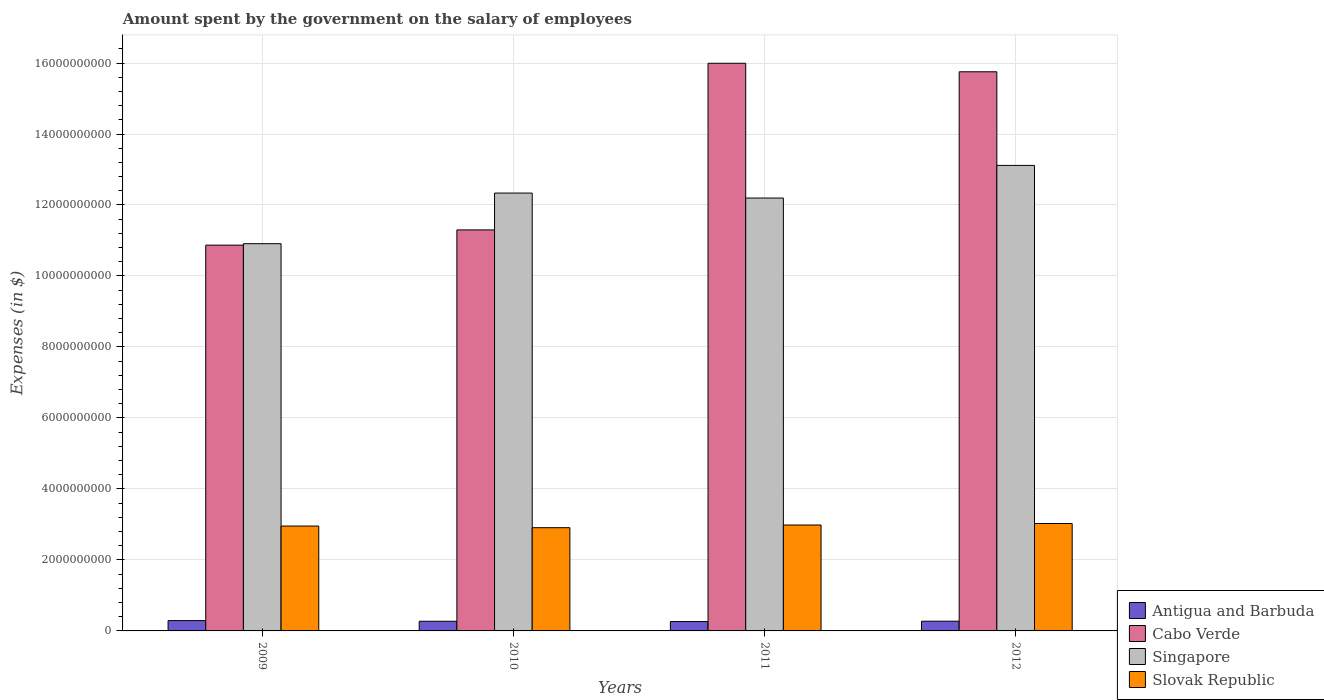How many different coloured bars are there?
Offer a very short reply. 4. How many groups of bars are there?
Offer a very short reply. 4. Are the number of bars per tick equal to the number of legend labels?
Offer a terse response. Yes. Are the number of bars on each tick of the X-axis equal?
Keep it short and to the point. Yes. How many bars are there on the 4th tick from the right?
Ensure brevity in your answer.  4. What is the label of the 4th group of bars from the left?
Provide a short and direct response. 2012. In how many cases, is the number of bars for a given year not equal to the number of legend labels?
Ensure brevity in your answer.  0. What is the amount spent on the salary of employees by the government in Singapore in 2010?
Provide a succinct answer. 1.23e+1. Across all years, what is the maximum amount spent on the salary of employees by the government in Cabo Verde?
Your response must be concise. 1.60e+1. Across all years, what is the minimum amount spent on the salary of employees by the government in Antigua and Barbuda?
Offer a terse response. 2.64e+08. In which year was the amount spent on the salary of employees by the government in Slovak Republic maximum?
Your answer should be compact. 2012. In which year was the amount spent on the salary of employees by the government in Antigua and Barbuda minimum?
Offer a very short reply. 2011. What is the total amount spent on the salary of employees by the government in Antigua and Barbuda in the graph?
Make the answer very short. 1.10e+09. What is the difference between the amount spent on the salary of employees by the government in Antigua and Barbuda in 2011 and that in 2012?
Provide a succinct answer. -9.90e+06. What is the difference between the amount spent on the salary of employees by the government in Antigua and Barbuda in 2010 and the amount spent on the salary of employees by the government in Cabo Verde in 2012?
Your response must be concise. -1.55e+1. What is the average amount spent on the salary of employees by the government in Singapore per year?
Offer a terse response. 1.21e+1. In the year 2012, what is the difference between the amount spent on the salary of employees by the government in Singapore and amount spent on the salary of employees by the government in Slovak Republic?
Offer a terse response. 1.01e+1. What is the ratio of the amount spent on the salary of employees by the government in Slovak Republic in 2010 to that in 2011?
Provide a succinct answer. 0.97. Is the amount spent on the salary of employees by the government in Antigua and Barbuda in 2011 less than that in 2012?
Offer a very short reply. Yes. What is the difference between the highest and the second highest amount spent on the salary of employees by the government in Slovak Republic?
Offer a terse response. 4.21e+07. What is the difference between the highest and the lowest amount spent on the salary of employees by the government in Antigua and Barbuda?
Your response must be concise. 2.68e+07. In how many years, is the amount spent on the salary of employees by the government in Antigua and Barbuda greater than the average amount spent on the salary of employees by the government in Antigua and Barbuda taken over all years?
Ensure brevity in your answer.  1. What does the 2nd bar from the left in 2009 represents?
Your response must be concise. Cabo Verde. What does the 1st bar from the right in 2011 represents?
Your answer should be very brief. Slovak Republic. How many bars are there?
Provide a short and direct response. 16. What is the difference between two consecutive major ticks on the Y-axis?
Offer a terse response. 2.00e+09. How many legend labels are there?
Offer a terse response. 4. How are the legend labels stacked?
Your answer should be very brief. Vertical. What is the title of the graph?
Your answer should be compact. Amount spent by the government on the salary of employees. Does "Trinidad and Tobago" appear as one of the legend labels in the graph?
Offer a very short reply. No. What is the label or title of the Y-axis?
Offer a terse response. Expenses (in $). What is the Expenses (in $) of Antigua and Barbuda in 2009?
Your response must be concise. 2.91e+08. What is the Expenses (in $) of Cabo Verde in 2009?
Give a very brief answer. 1.09e+1. What is the Expenses (in $) of Singapore in 2009?
Keep it short and to the point. 1.09e+1. What is the Expenses (in $) of Slovak Republic in 2009?
Ensure brevity in your answer.  2.96e+09. What is the Expenses (in $) in Antigua and Barbuda in 2010?
Make the answer very short. 2.73e+08. What is the Expenses (in $) in Cabo Verde in 2010?
Your answer should be very brief. 1.13e+1. What is the Expenses (in $) in Singapore in 2010?
Give a very brief answer. 1.23e+1. What is the Expenses (in $) in Slovak Republic in 2010?
Provide a short and direct response. 2.91e+09. What is the Expenses (in $) of Antigua and Barbuda in 2011?
Offer a terse response. 2.64e+08. What is the Expenses (in $) in Cabo Verde in 2011?
Make the answer very short. 1.60e+1. What is the Expenses (in $) of Singapore in 2011?
Ensure brevity in your answer.  1.22e+1. What is the Expenses (in $) of Slovak Republic in 2011?
Your answer should be compact. 2.98e+09. What is the Expenses (in $) of Antigua and Barbuda in 2012?
Your answer should be compact. 2.74e+08. What is the Expenses (in $) in Cabo Verde in 2012?
Ensure brevity in your answer.  1.58e+1. What is the Expenses (in $) of Singapore in 2012?
Provide a short and direct response. 1.31e+1. What is the Expenses (in $) in Slovak Republic in 2012?
Your answer should be very brief. 3.03e+09. Across all years, what is the maximum Expenses (in $) in Antigua and Barbuda?
Your answer should be compact. 2.91e+08. Across all years, what is the maximum Expenses (in $) of Cabo Verde?
Provide a short and direct response. 1.60e+1. Across all years, what is the maximum Expenses (in $) of Singapore?
Keep it short and to the point. 1.31e+1. Across all years, what is the maximum Expenses (in $) in Slovak Republic?
Keep it short and to the point. 3.03e+09. Across all years, what is the minimum Expenses (in $) in Antigua and Barbuda?
Give a very brief answer. 2.64e+08. Across all years, what is the minimum Expenses (in $) of Cabo Verde?
Your answer should be very brief. 1.09e+1. Across all years, what is the minimum Expenses (in $) in Singapore?
Provide a short and direct response. 1.09e+1. Across all years, what is the minimum Expenses (in $) in Slovak Republic?
Your answer should be very brief. 2.91e+09. What is the total Expenses (in $) in Antigua and Barbuda in the graph?
Keep it short and to the point. 1.10e+09. What is the total Expenses (in $) of Cabo Verde in the graph?
Make the answer very short. 5.39e+1. What is the total Expenses (in $) of Singapore in the graph?
Offer a very short reply. 4.86e+1. What is the total Expenses (in $) of Slovak Republic in the graph?
Offer a terse response. 1.19e+1. What is the difference between the Expenses (in $) in Antigua and Barbuda in 2009 and that in 2010?
Offer a very short reply. 1.81e+07. What is the difference between the Expenses (in $) of Cabo Verde in 2009 and that in 2010?
Your answer should be compact. -4.29e+08. What is the difference between the Expenses (in $) in Singapore in 2009 and that in 2010?
Make the answer very short. -1.43e+09. What is the difference between the Expenses (in $) in Slovak Republic in 2009 and that in 2010?
Ensure brevity in your answer.  4.65e+07. What is the difference between the Expenses (in $) in Antigua and Barbuda in 2009 and that in 2011?
Provide a succinct answer. 2.68e+07. What is the difference between the Expenses (in $) in Cabo Verde in 2009 and that in 2011?
Ensure brevity in your answer.  -5.12e+09. What is the difference between the Expenses (in $) in Singapore in 2009 and that in 2011?
Offer a very short reply. -1.29e+09. What is the difference between the Expenses (in $) of Slovak Republic in 2009 and that in 2011?
Your answer should be very brief. -2.92e+07. What is the difference between the Expenses (in $) of Antigua and Barbuda in 2009 and that in 2012?
Your response must be concise. 1.69e+07. What is the difference between the Expenses (in $) in Cabo Verde in 2009 and that in 2012?
Offer a very short reply. -4.88e+09. What is the difference between the Expenses (in $) in Singapore in 2009 and that in 2012?
Your response must be concise. -2.21e+09. What is the difference between the Expenses (in $) in Slovak Republic in 2009 and that in 2012?
Offer a very short reply. -7.13e+07. What is the difference between the Expenses (in $) in Antigua and Barbuda in 2010 and that in 2011?
Your answer should be compact. 8.70e+06. What is the difference between the Expenses (in $) in Cabo Verde in 2010 and that in 2011?
Your response must be concise. -4.70e+09. What is the difference between the Expenses (in $) of Singapore in 2010 and that in 2011?
Give a very brief answer. 1.40e+08. What is the difference between the Expenses (in $) of Slovak Republic in 2010 and that in 2011?
Give a very brief answer. -7.57e+07. What is the difference between the Expenses (in $) in Antigua and Barbuda in 2010 and that in 2012?
Offer a terse response. -1.20e+06. What is the difference between the Expenses (in $) of Cabo Verde in 2010 and that in 2012?
Keep it short and to the point. -4.45e+09. What is the difference between the Expenses (in $) of Singapore in 2010 and that in 2012?
Ensure brevity in your answer.  -7.80e+08. What is the difference between the Expenses (in $) of Slovak Republic in 2010 and that in 2012?
Provide a short and direct response. -1.18e+08. What is the difference between the Expenses (in $) of Antigua and Barbuda in 2011 and that in 2012?
Offer a very short reply. -9.90e+06. What is the difference between the Expenses (in $) in Cabo Verde in 2011 and that in 2012?
Offer a terse response. 2.40e+08. What is the difference between the Expenses (in $) of Singapore in 2011 and that in 2012?
Your answer should be very brief. -9.20e+08. What is the difference between the Expenses (in $) in Slovak Republic in 2011 and that in 2012?
Provide a short and direct response. -4.21e+07. What is the difference between the Expenses (in $) of Antigua and Barbuda in 2009 and the Expenses (in $) of Cabo Verde in 2010?
Provide a succinct answer. -1.10e+1. What is the difference between the Expenses (in $) in Antigua and Barbuda in 2009 and the Expenses (in $) in Singapore in 2010?
Offer a very short reply. -1.20e+1. What is the difference between the Expenses (in $) in Antigua and Barbuda in 2009 and the Expenses (in $) in Slovak Republic in 2010?
Your answer should be very brief. -2.62e+09. What is the difference between the Expenses (in $) in Cabo Verde in 2009 and the Expenses (in $) in Singapore in 2010?
Make the answer very short. -1.47e+09. What is the difference between the Expenses (in $) in Cabo Verde in 2009 and the Expenses (in $) in Slovak Republic in 2010?
Your answer should be very brief. 7.96e+09. What is the difference between the Expenses (in $) in Singapore in 2009 and the Expenses (in $) in Slovak Republic in 2010?
Your answer should be very brief. 8.00e+09. What is the difference between the Expenses (in $) of Antigua and Barbuda in 2009 and the Expenses (in $) of Cabo Verde in 2011?
Your response must be concise. -1.57e+1. What is the difference between the Expenses (in $) in Antigua and Barbuda in 2009 and the Expenses (in $) in Singapore in 2011?
Offer a terse response. -1.19e+1. What is the difference between the Expenses (in $) in Antigua and Barbuda in 2009 and the Expenses (in $) in Slovak Republic in 2011?
Make the answer very short. -2.69e+09. What is the difference between the Expenses (in $) in Cabo Verde in 2009 and the Expenses (in $) in Singapore in 2011?
Offer a terse response. -1.33e+09. What is the difference between the Expenses (in $) of Cabo Verde in 2009 and the Expenses (in $) of Slovak Republic in 2011?
Provide a succinct answer. 7.89e+09. What is the difference between the Expenses (in $) in Singapore in 2009 and the Expenses (in $) in Slovak Republic in 2011?
Make the answer very short. 7.93e+09. What is the difference between the Expenses (in $) in Antigua and Barbuda in 2009 and the Expenses (in $) in Cabo Verde in 2012?
Provide a succinct answer. -1.55e+1. What is the difference between the Expenses (in $) in Antigua and Barbuda in 2009 and the Expenses (in $) in Singapore in 2012?
Your response must be concise. -1.28e+1. What is the difference between the Expenses (in $) in Antigua and Barbuda in 2009 and the Expenses (in $) in Slovak Republic in 2012?
Provide a succinct answer. -2.74e+09. What is the difference between the Expenses (in $) of Cabo Verde in 2009 and the Expenses (in $) of Singapore in 2012?
Make the answer very short. -2.25e+09. What is the difference between the Expenses (in $) of Cabo Verde in 2009 and the Expenses (in $) of Slovak Republic in 2012?
Give a very brief answer. 7.84e+09. What is the difference between the Expenses (in $) in Singapore in 2009 and the Expenses (in $) in Slovak Republic in 2012?
Your answer should be compact. 7.88e+09. What is the difference between the Expenses (in $) of Antigua and Barbuda in 2010 and the Expenses (in $) of Cabo Verde in 2011?
Give a very brief answer. -1.57e+1. What is the difference between the Expenses (in $) in Antigua and Barbuda in 2010 and the Expenses (in $) in Singapore in 2011?
Provide a succinct answer. -1.19e+1. What is the difference between the Expenses (in $) of Antigua and Barbuda in 2010 and the Expenses (in $) of Slovak Republic in 2011?
Offer a very short reply. -2.71e+09. What is the difference between the Expenses (in $) in Cabo Verde in 2010 and the Expenses (in $) in Singapore in 2011?
Your response must be concise. -8.98e+08. What is the difference between the Expenses (in $) in Cabo Verde in 2010 and the Expenses (in $) in Slovak Republic in 2011?
Ensure brevity in your answer.  8.31e+09. What is the difference between the Expenses (in $) of Singapore in 2010 and the Expenses (in $) of Slovak Republic in 2011?
Your answer should be very brief. 9.35e+09. What is the difference between the Expenses (in $) of Antigua and Barbuda in 2010 and the Expenses (in $) of Cabo Verde in 2012?
Keep it short and to the point. -1.55e+1. What is the difference between the Expenses (in $) in Antigua and Barbuda in 2010 and the Expenses (in $) in Singapore in 2012?
Your answer should be compact. -1.28e+1. What is the difference between the Expenses (in $) of Antigua and Barbuda in 2010 and the Expenses (in $) of Slovak Republic in 2012?
Offer a very short reply. -2.75e+09. What is the difference between the Expenses (in $) in Cabo Verde in 2010 and the Expenses (in $) in Singapore in 2012?
Your answer should be very brief. -1.82e+09. What is the difference between the Expenses (in $) of Cabo Verde in 2010 and the Expenses (in $) of Slovak Republic in 2012?
Offer a very short reply. 8.27e+09. What is the difference between the Expenses (in $) of Singapore in 2010 and the Expenses (in $) of Slovak Republic in 2012?
Your response must be concise. 9.31e+09. What is the difference between the Expenses (in $) of Antigua and Barbuda in 2011 and the Expenses (in $) of Cabo Verde in 2012?
Provide a succinct answer. -1.55e+1. What is the difference between the Expenses (in $) of Antigua and Barbuda in 2011 and the Expenses (in $) of Singapore in 2012?
Ensure brevity in your answer.  -1.29e+1. What is the difference between the Expenses (in $) in Antigua and Barbuda in 2011 and the Expenses (in $) in Slovak Republic in 2012?
Provide a short and direct response. -2.76e+09. What is the difference between the Expenses (in $) of Cabo Verde in 2011 and the Expenses (in $) of Singapore in 2012?
Give a very brief answer. 2.88e+09. What is the difference between the Expenses (in $) of Cabo Verde in 2011 and the Expenses (in $) of Slovak Republic in 2012?
Your answer should be compact. 1.30e+1. What is the difference between the Expenses (in $) of Singapore in 2011 and the Expenses (in $) of Slovak Republic in 2012?
Offer a terse response. 9.17e+09. What is the average Expenses (in $) in Antigua and Barbuda per year?
Keep it short and to the point. 2.75e+08. What is the average Expenses (in $) of Cabo Verde per year?
Ensure brevity in your answer.  1.35e+1. What is the average Expenses (in $) of Singapore per year?
Keep it short and to the point. 1.21e+1. What is the average Expenses (in $) in Slovak Republic per year?
Offer a very short reply. 2.97e+09. In the year 2009, what is the difference between the Expenses (in $) in Antigua and Barbuda and Expenses (in $) in Cabo Verde?
Your answer should be compact. -1.06e+1. In the year 2009, what is the difference between the Expenses (in $) in Antigua and Barbuda and Expenses (in $) in Singapore?
Provide a short and direct response. -1.06e+1. In the year 2009, what is the difference between the Expenses (in $) of Antigua and Barbuda and Expenses (in $) of Slovak Republic?
Your response must be concise. -2.66e+09. In the year 2009, what is the difference between the Expenses (in $) of Cabo Verde and Expenses (in $) of Singapore?
Ensure brevity in your answer.  -4.07e+07. In the year 2009, what is the difference between the Expenses (in $) of Cabo Verde and Expenses (in $) of Slovak Republic?
Your answer should be very brief. 7.91e+09. In the year 2009, what is the difference between the Expenses (in $) in Singapore and Expenses (in $) in Slovak Republic?
Offer a very short reply. 7.95e+09. In the year 2010, what is the difference between the Expenses (in $) of Antigua and Barbuda and Expenses (in $) of Cabo Verde?
Provide a short and direct response. -1.10e+1. In the year 2010, what is the difference between the Expenses (in $) of Antigua and Barbuda and Expenses (in $) of Singapore?
Provide a succinct answer. -1.21e+1. In the year 2010, what is the difference between the Expenses (in $) of Antigua and Barbuda and Expenses (in $) of Slovak Republic?
Give a very brief answer. -2.64e+09. In the year 2010, what is the difference between the Expenses (in $) in Cabo Verde and Expenses (in $) in Singapore?
Your answer should be very brief. -1.04e+09. In the year 2010, what is the difference between the Expenses (in $) of Cabo Verde and Expenses (in $) of Slovak Republic?
Give a very brief answer. 8.39e+09. In the year 2010, what is the difference between the Expenses (in $) in Singapore and Expenses (in $) in Slovak Republic?
Provide a short and direct response. 9.43e+09. In the year 2011, what is the difference between the Expenses (in $) in Antigua and Barbuda and Expenses (in $) in Cabo Verde?
Provide a short and direct response. -1.57e+1. In the year 2011, what is the difference between the Expenses (in $) in Antigua and Barbuda and Expenses (in $) in Singapore?
Provide a succinct answer. -1.19e+1. In the year 2011, what is the difference between the Expenses (in $) of Antigua and Barbuda and Expenses (in $) of Slovak Republic?
Your response must be concise. -2.72e+09. In the year 2011, what is the difference between the Expenses (in $) in Cabo Verde and Expenses (in $) in Singapore?
Make the answer very short. 3.80e+09. In the year 2011, what is the difference between the Expenses (in $) of Cabo Verde and Expenses (in $) of Slovak Republic?
Make the answer very short. 1.30e+1. In the year 2011, what is the difference between the Expenses (in $) of Singapore and Expenses (in $) of Slovak Republic?
Make the answer very short. 9.21e+09. In the year 2012, what is the difference between the Expenses (in $) in Antigua and Barbuda and Expenses (in $) in Cabo Verde?
Your answer should be very brief. -1.55e+1. In the year 2012, what is the difference between the Expenses (in $) of Antigua and Barbuda and Expenses (in $) of Singapore?
Provide a short and direct response. -1.28e+1. In the year 2012, what is the difference between the Expenses (in $) of Antigua and Barbuda and Expenses (in $) of Slovak Republic?
Keep it short and to the point. -2.75e+09. In the year 2012, what is the difference between the Expenses (in $) of Cabo Verde and Expenses (in $) of Singapore?
Your answer should be very brief. 2.64e+09. In the year 2012, what is the difference between the Expenses (in $) of Cabo Verde and Expenses (in $) of Slovak Republic?
Your answer should be very brief. 1.27e+1. In the year 2012, what is the difference between the Expenses (in $) of Singapore and Expenses (in $) of Slovak Republic?
Provide a succinct answer. 1.01e+1. What is the ratio of the Expenses (in $) in Antigua and Barbuda in 2009 to that in 2010?
Your answer should be very brief. 1.07. What is the ratio of the Expenses (in $) of Cabo Verde in 2009 to that in 2010?
Make the answer very short. 0.96. What is the ratio of the Expenses (in $) of Singapore in 2009 to that in 2010?
Keep it short and to the point. 0.88. What is the ratio of the Expenses (in $) in Antigua and Barbuda in 2009 to that in 2011?
Offer a very short reply. 1.1. What is the ratio of the Expenses (in $) in Cabo Verde in 2009 to that in 2011?
Your response must be concise. 0.68. What is the ratio of the Expenses (in $) in Singapore in 2009 to that in 2011?
Ensure brevity in your answer.  0.89. What is the ratio of the Expenses (in $) in Slovak Republic in 2009 to that in 2011?
Offer a very short reply. 0.99. What is the ratio of the Expenses (in $) in Antigua and Barbuda in 2009 to that in 2012?
Offer a very short reply. 1.06. What is the ratio of the Expenses (in $) of Cabo Verde in 2009 to that in 2012?
Offer a terse response. 0.69. What is the ratio of the Expenses (in $) of Singapore in 2009 to that in 2012?
Your response must be concise. 0.83. What is the ratio of the Expenses (in $) of Slovak Republic in 2009 to that in 2012?
Provide a succinct answer. 0.98. What is the ratio of the Expenses (in $) of Antigua and Barbuda in 2010 to that in 2011?
Your response must be concise. 1.03. What is the ratio of the Expenses (in $) of Cabo Verde in 2010 to that in 2011?
Ensure brevity in your answer.  0.71. What is the ratio of the Expenses (in $) in Singapore in 2010 to that in 2011?
Offer a very short reply. 1.01. What is the ratio of the Expenses (in $) of Slovak Republic in 2010 to that in 2011?
Provide a succinct answer. 0.97. What is the ratio of the Expenses (in $) in Cabo Verde in 2010 to that in 2012?
Your answer should be very brief. 0.72. What is the ratio of the Expenses (in $) of Singapore in 2010 to that in 2012?
Your answer should be compact. 0.94. What is the ratio of the Expenses (in $) in Slovak Republic in 2010 to that in 2012?
Your answer should be very brief. 0.96. What is the ratio of the Expenses (in $) in Antigua and Barbuda in 2011 to that in 2012?
Ensure brevity in your answer.  0.96. What is the ratio of the Expenses (in $) of Cabo Verde in 2011 to that in 2012?
Your answer should be compact. 1.02. What is the ratio of the Expenses (in $) of Singapore in 2011 to that in 2012?
Keep it short and to the point. 0.93. What is the ratio of the Expenses (in $) in Slovak Republic in 2011 to that in 2012?
Your answer should be compact. 0.99. What is the difference between the highest and the second highest Expenses (in $) of Antigua and Barbuda?
Your response must be concise. 1.69e+07. What is the difference between the highest and the second highest Expenses (in $) in Cabo Verde?
Your answer should be compact. 2.40e+08. What is the difference between the highest and the second highest Expenses (in $) of Singapore?
Your answer should be very brief. 7.80e+08. What is the difference between the highest and the second highest Expenses (in $) of Slovak Republic?
Ensure brevity in your answer.  4.21e+07. What is the difference between the highest and the lowest Expenses (in $) of Antigua and Barbuda?
Provide a succinct answer. 2.68e+07. What is the difference between the highest and the lowest Expenses (in $) of Cabo Verde?
Your answer should be compact. 5.12e+09. What is the difference between the highest and the lowest Expenses (in $) of Singapore?
Keep it short and to the point. 2.21e+09. What is the difference between the highest and the lowest Expenses (in $) of Slovak Republic?
Provide a short and direct response. 1.18e+08. 